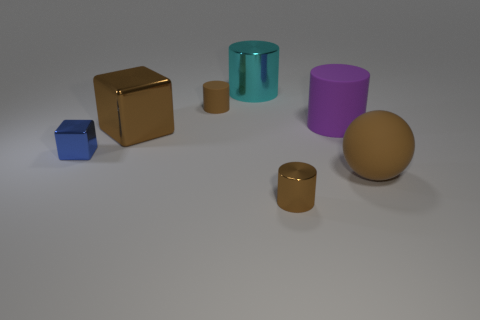What number of purple objects are the same material as the large purple cylinder?
Provide a short and direct response. 0. There is a brown metal thing right of the matte cylinder that is left of the cyan cylinder; are there any big brown spheres that are left of it?
Provide a succinct answer. No. What is the shape of the small rubber object?
Keep it short and to the point. Cylinder. Is the tiny block in front of the purple rubber object made of the same material as the large object that is in front of the large block?
Ensure brevity in your answer.  No. How many small shiny cylinders are the same color as the big sphere?
Your answer should be compact. 1. There is a big object that is both in front of the cyan metal thing and left of the big rubber cylinder; what shape is it?
Your answer should be very brief. Cube. What color is the cylinder that is left of the big purple thing and right of the cyan shiny object?
Give a very brief answer. Brown. Is the number of brown cylinders on the right side of the cyan thing greater than the number of large objects that are behind the big purple matte object?
Give a very brief answer. No. There is a small metallic thing that is behind the matte ball; what is its color?
Provide a succinct answer. Blue. Do the tiny brown thing that is in front of the big brown matte sphere and the brown rubber object that is to the right of the purple cylinder have the same shape?
Your answer should be very brief. No. 